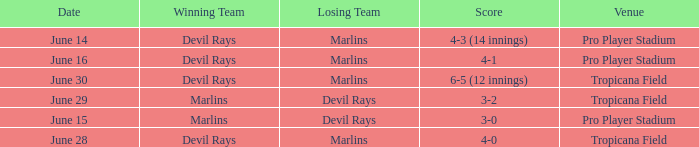What was the score on june 29? 3-2. 